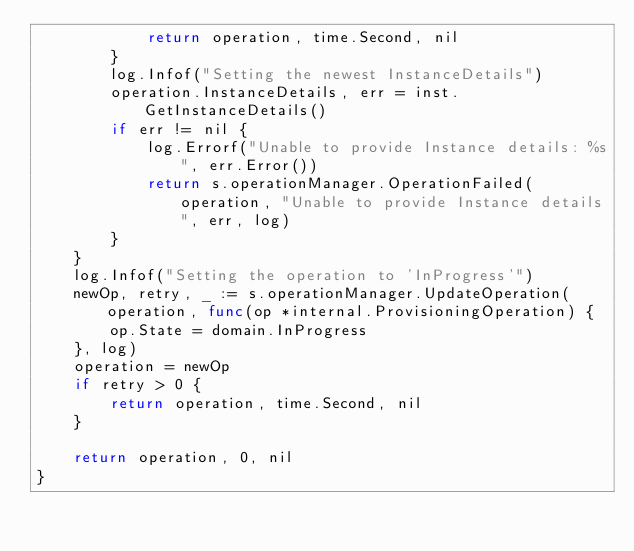<code> <loc_0><loc_0><loc_500><loc_500><_Go_>			return operation, time.Second, nil
		}
		log.Infof("Setting the newest InstanceDetails")
		operation.InstanceDetails, err = inst.GetInstanceDetails()
		if err != nil {
			log.Errorf("Unable to provide Instance details: %s", err.Error())
			return s.operationManager.OperationFailed(operation, "Unable to provide Instance details", err, log)
		}
	}
	log.Infof("Setting the operation to 'InProgress'")
	newOp, retry, _ := s.operationManager.UpdateOperation(operation, func(op *internal.ProvisioningOperation) {
		op.State = domain.InProgress
	}, log)
	operation = newOp
	if retry > 0 {
		return operation, time.Second, nil
	}

	return operation, 0, nil
}
</code> 